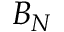Convert formula to latex. <formula><loc_0><loc_0><loc_500><loc_500>B _ { N }</formula> 